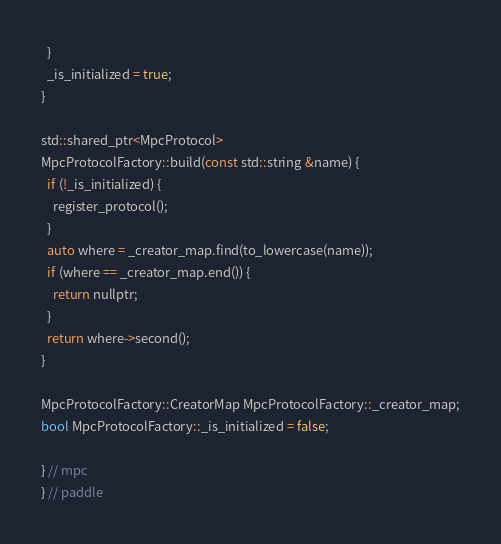Convert code to text. <code><loc_0><loc_0><loc_500><loc_500><_Cuda_>  }
  _is_initialized = true;
}

std::shared_ptr<MpcProtocol>
MpcProtocolFactory::build(const std::string &name) {
  if (!_is_initialized) {
    register_protocol();
  }
  auto where = _creator_map.find(to_lowercase(name));
  if (where == _creator_map.end()) {
    return nullptr;
  }
  return where->second();
}

MpcProtocolFactory::CreatorMap MpcProtocolFactory::_creator_map;
bool MpcProtocolFactory::_is_initialized = false;

} // mpc
} // paddle
</code> 